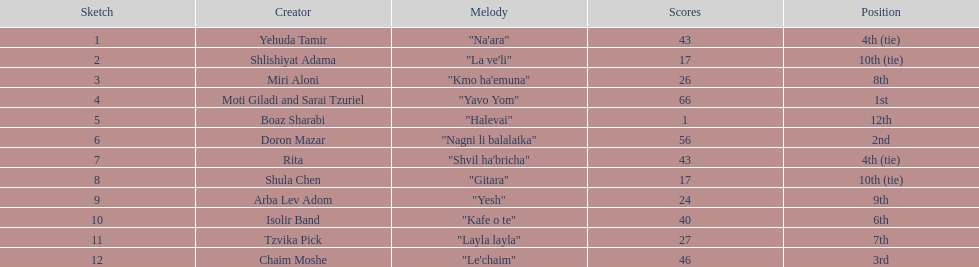Compare draws, which had the least amount of points? Boaz Sharabi. 